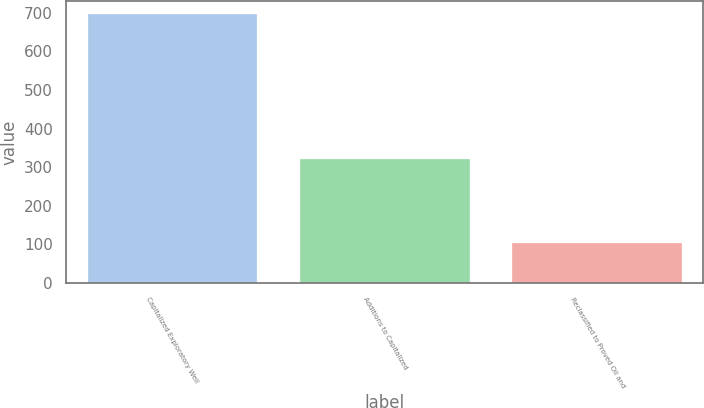Convert chart. <chart><loc_0><loc_0><loc_500><loc_500><bar_chart><fcel>Capitalized Exploratory Well<fcel>Additions to Capitalized<fcel>Reclassified to Proved Oil and<nl><fcel>696<fcel>322<fcel>102.9<nl></chart> 